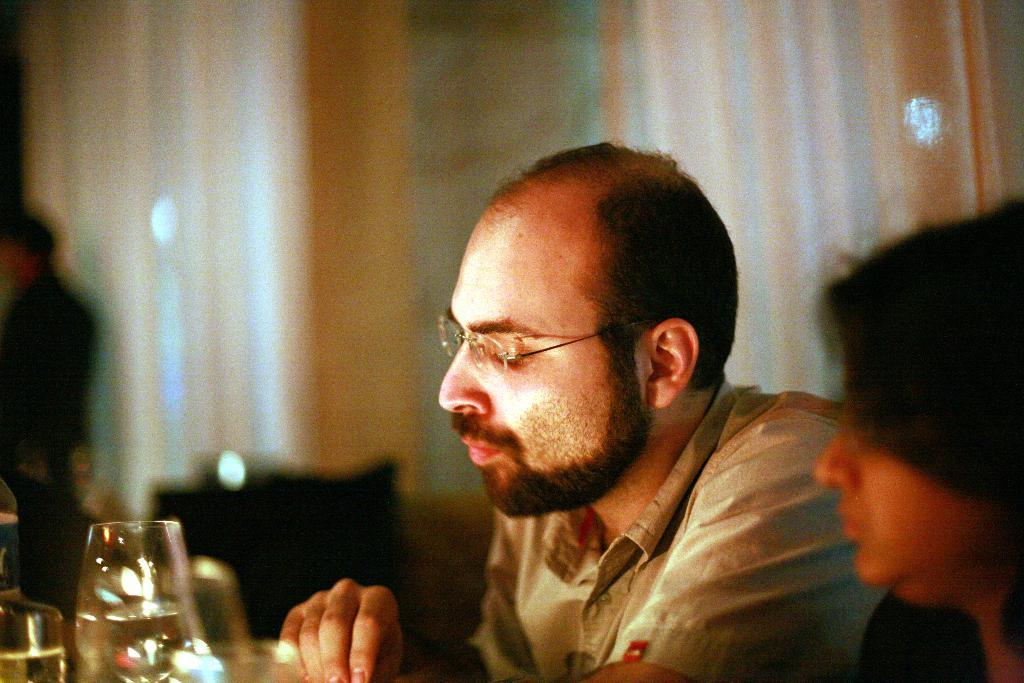Who is present in the image? There is a man and a woman in the image. What are the man and woman doing in the image? Both the man and woman are sitting on chairs. What objects are in front of them? There are glasses in front of them. Can you describe the background of the image? The background of the image is blurred. What type of mask is the man wearing in the image? There is no mask present in the image; both the man and woman are not wearing any masks. 